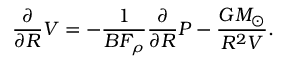<formula> <loc_0><loc_0><loc_500><loc_500>\frac { \partial } { \partial R } V = - \frac { 1 } { B F _ { \rho } } \frac { \partial } { \partial R } P - \frac { G M _ { \odot } } { R ^ { 2 } V } .</formula> 